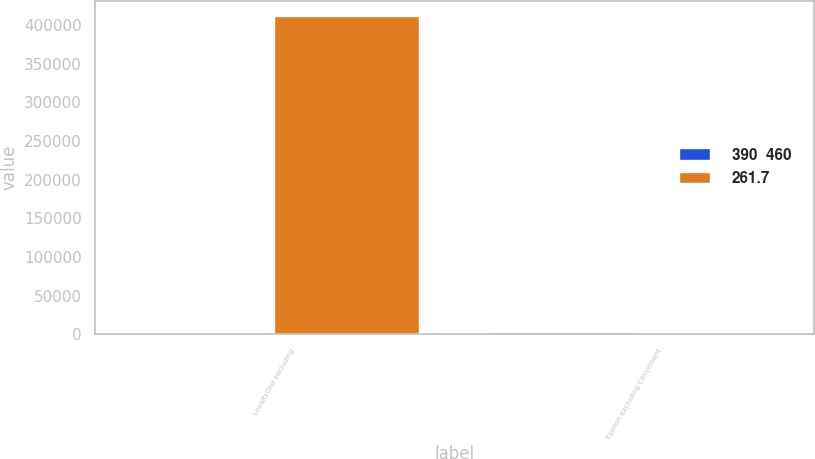Convert chart to OTSL. <chart><loc_0><loc_0><loc_500><loc_500><stacked_bar_chart><ecel><fcel>LoyaltyOne excluding<fcel>Epsilon excluding Conversant<nl><fcel>390  460<fcel>183.7<fcel>1235.8<nl><fcel>261.7<fcel>410440<fcel>30<nl></chart> 